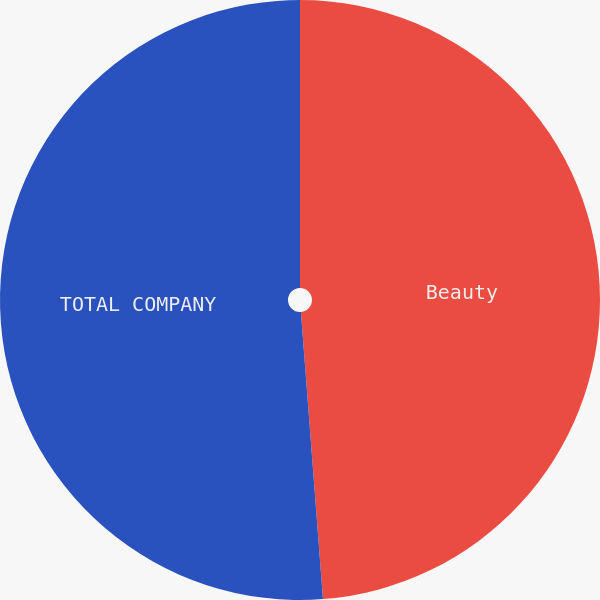Convert chart. <chart><loc_0><loc_0><loc_500><loc_500><pie_chart><fcel>Beauty<fcel>TOTAL COMPANY<nl><fcel>48.78%<fcel>51.22%<nl></chart> 